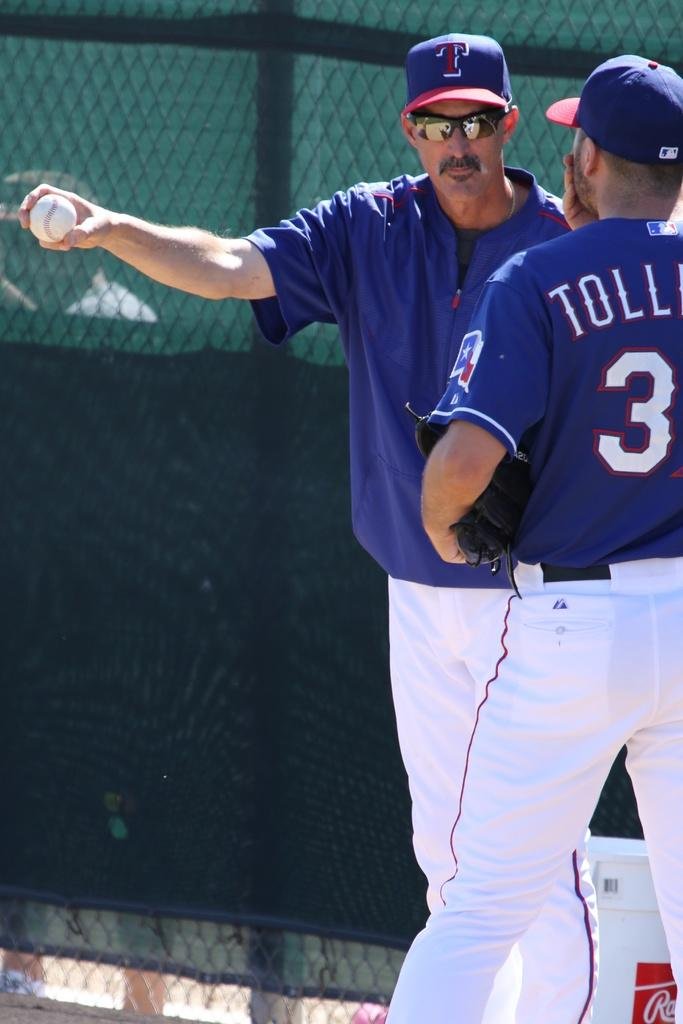<image>
Write a terse but informative summary of the picture. Two people on a baseball team for T as shown on their hats 